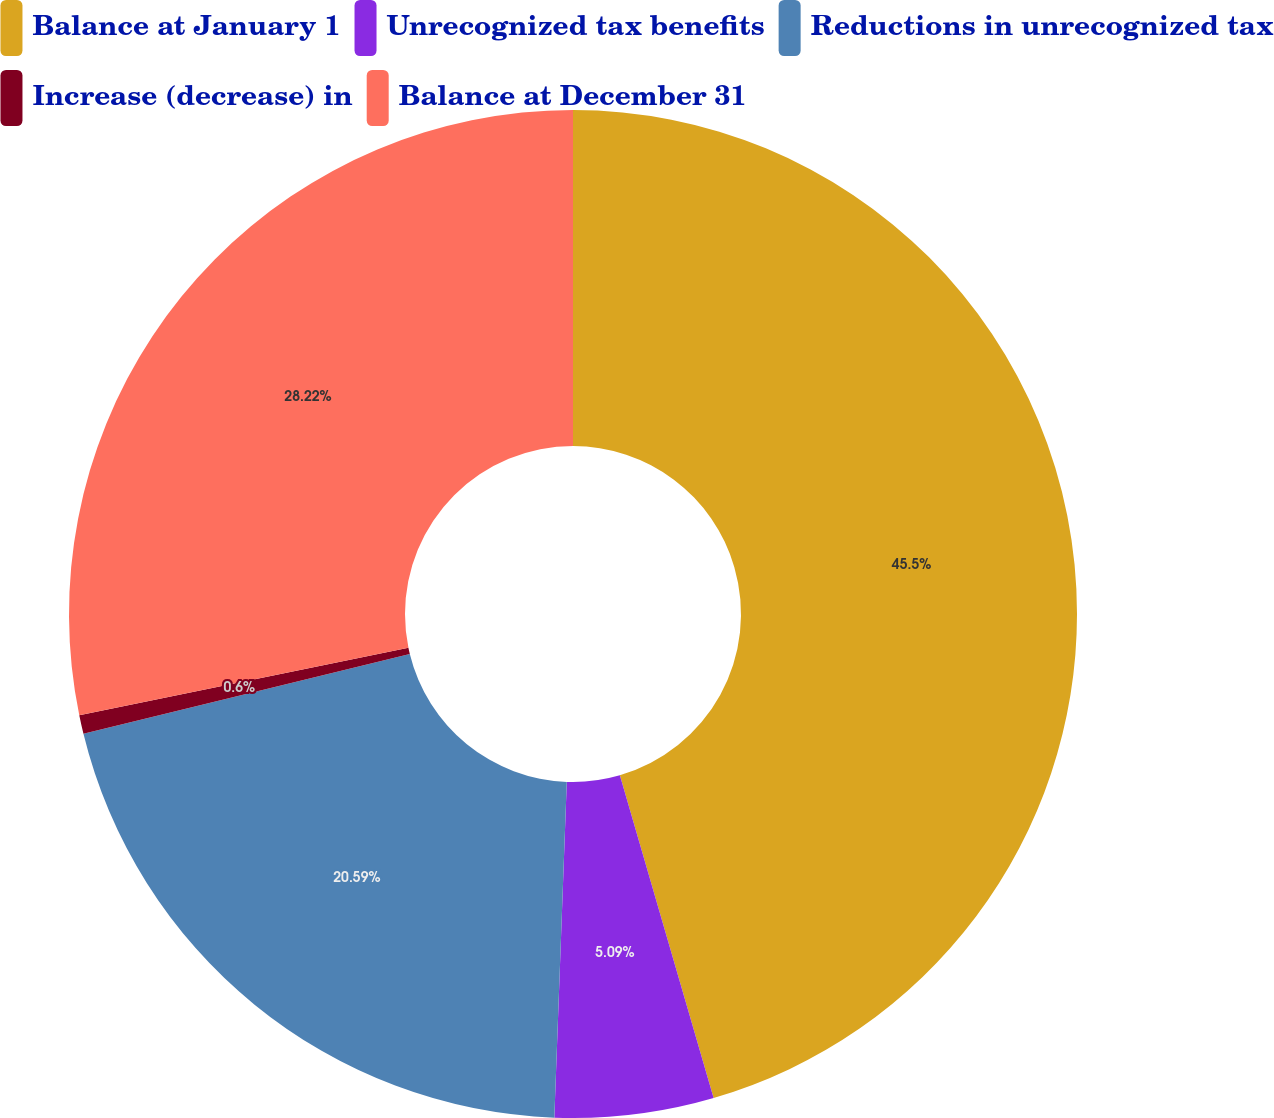Convert chart to OTSL. <chart><loc_0><loc_0><loc_500><loc_500><pie_chart><fcel>Balance at January 1<fcel>Unrecognized tax benefits<fcel>Reductions in unrecognized tax<fcel>Increase (decrease) in<fcel>Balance at December 31<nl><fcel>45.5%<fcel>5.09%<fcel>20.59%<fcel>0.6%<fcel>28.22%<nl></chart> 